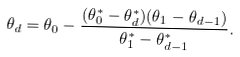Convert formula to latex. <formula><loc_0><loc_0><loc_500><loc_500>\theta _ { d } = \theta _ { 0 } - \frac { ( \theta ^ { * } _ { 0 } - \theta ^ { * } _ { d } ) ( \theta _ { 1 } - \theta _ { d - 1 } ) } { \theta ^ { * } _ { 1 } - \theta ^ { * } _ { d - 1 } } .</formula> 